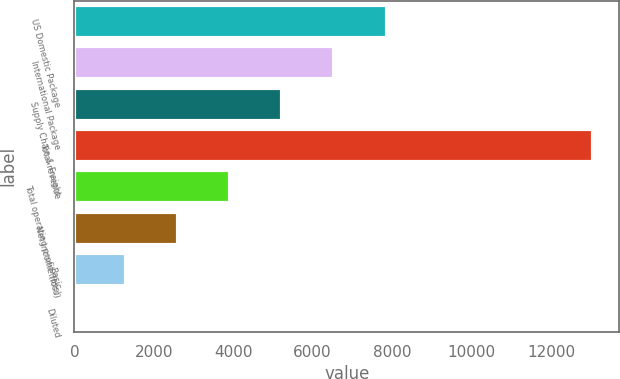Convert chart to OTSL. <chart><loc_0><loc_0><loc_500><loc_500><bar_chart><fcel>US Domestic Package<fcel>International Package<fcel>Supply Chain & Freight<fcel>Total revenue<fcel>Total operating profit (loss)<fcel>Net income (loss)<fcel>Basic<fcel>Diluted<nl><fcel>7861<fcel>6535.73<fcel>5228.68<fcel>13071<fcel>3921.63<fcel>2614.58<fcel>1307.53<fcel>0.48<nl></chart> 